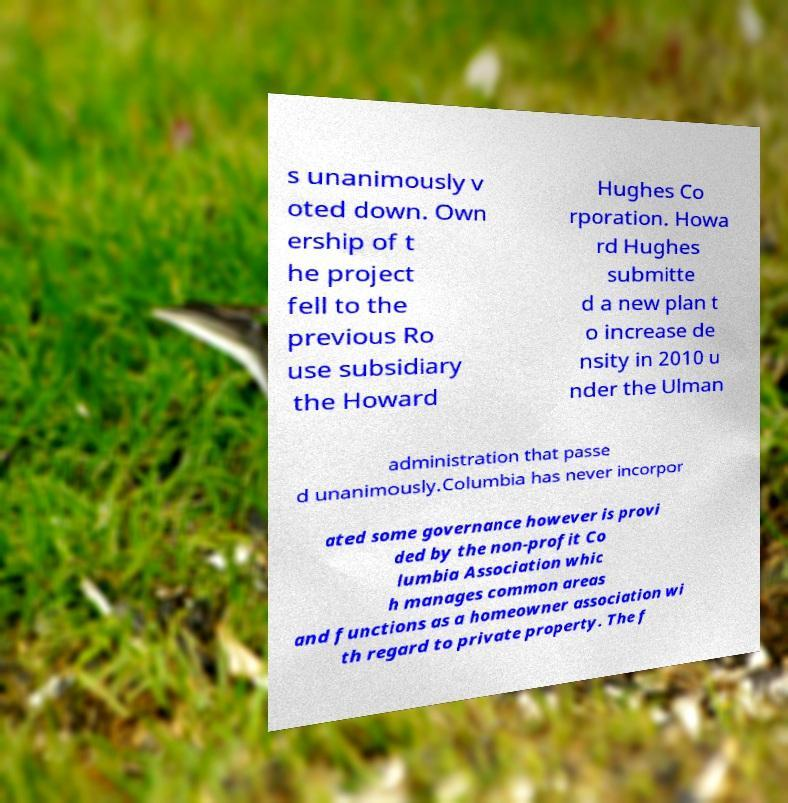Can you read and provide the text displayed in the image?This photo seems to have some interesting text. Can you extract and type it out for me? s unanimously v oted down. Own ership of t he project fell to the previous Ro use subsidiary the Howard Hughes Co rporation. Howa rd Hughes submitte d a new plan t o increase de nsity in 2010 u nder the Ulman administration that passe d unanimously.Columbia has never incorpor ated some governance however is provi ded by the non-profit Co lumbia Association whic h manages common areas and functions as a homeowner association wi th regard to private property. The f 